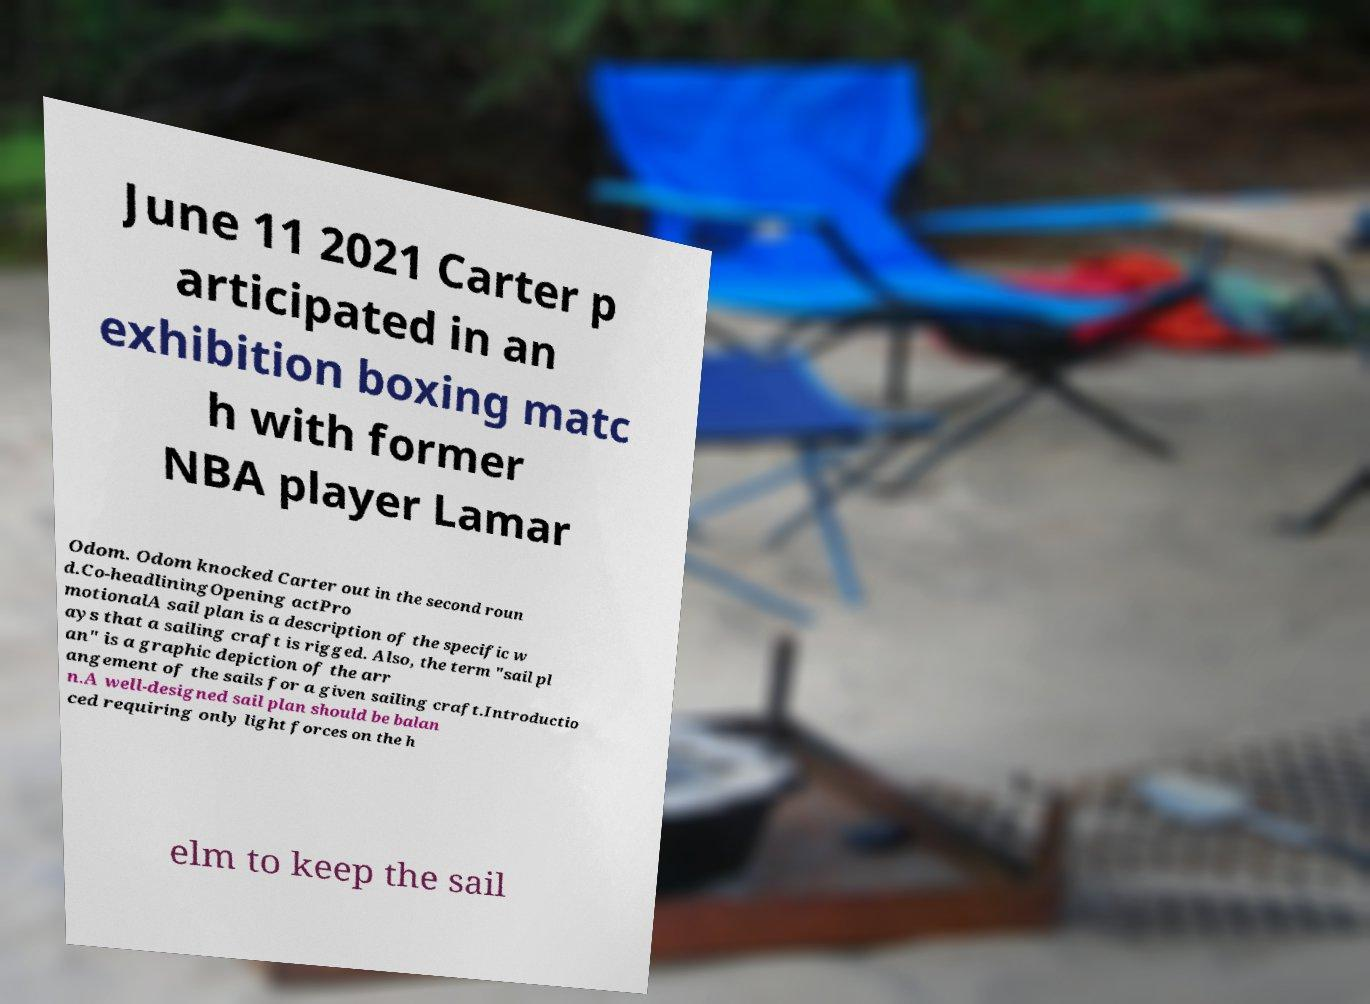I need the written content from this picture converted into text. Can you do that? June 11 2021 Carter p articipated in an exhibition boxing matc h with former NBA player Lamar Odom. Odom knocked Carter out in the second roun d.Co-headliningOpening actPro motionalA sail plan is a description of the specific w ays that a sailing craft is rigged. Also, the term "sail pl an" is a graphic depiction of the arr angement of the sails for a given sailing craft.Introductio n.A well-designed sail plan should be balan ced requiring only light forces on the h elm to keep the sail 